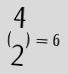<formula> <loc_0><loc_0><loc_500><loc_500>( \begin{matrix} 4 \\ 2 \end{matrix} ) = 6</formula> 